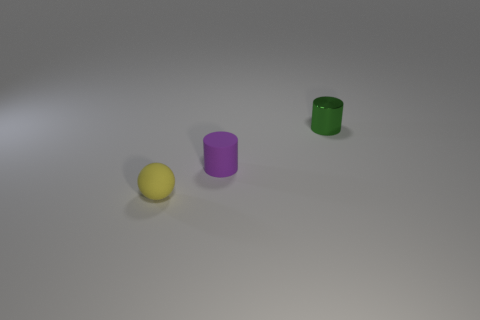What material do these objects appear to be made from? The objects in the image appear to have a matte surface, suggesting they could be made of plastic or some kind of painted material. 